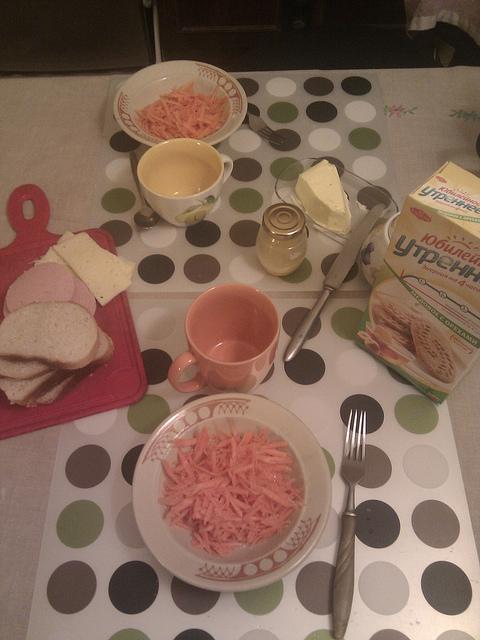Is this meal over or just beginning?
Be succinct. Beginning. Is there a doll in the picture?
Give a very brief answer. No. What color is the place mat?
Concise answer only. White. Where is the fork?
Be succinct. Right. What is the food called on the right?
Be succinct. Cereal. Are there strawberries in a bowl?
Quick response, please. No. Is there bread on the cutting board?
Short answer required. Yes. Is this for a wedding or a kids birthday party?
Concise answer only. Neither. What kind of bread is in the photo?
Concise answer only. Rye. How many bowels are on the table?
Be succinct. 0. 